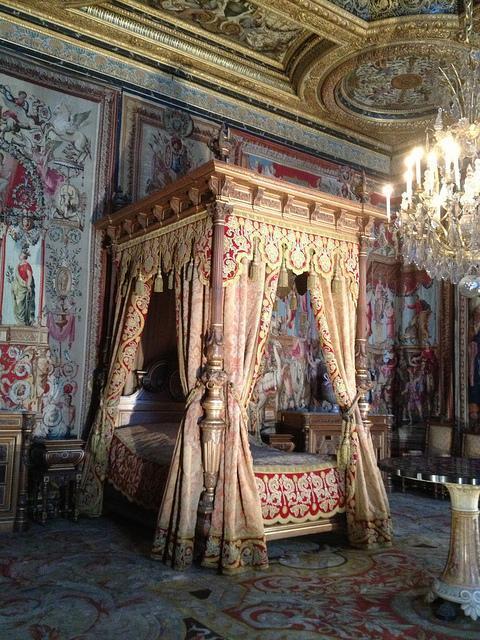How many people are sitting on the bed?
Give a very brief answer. 0. 